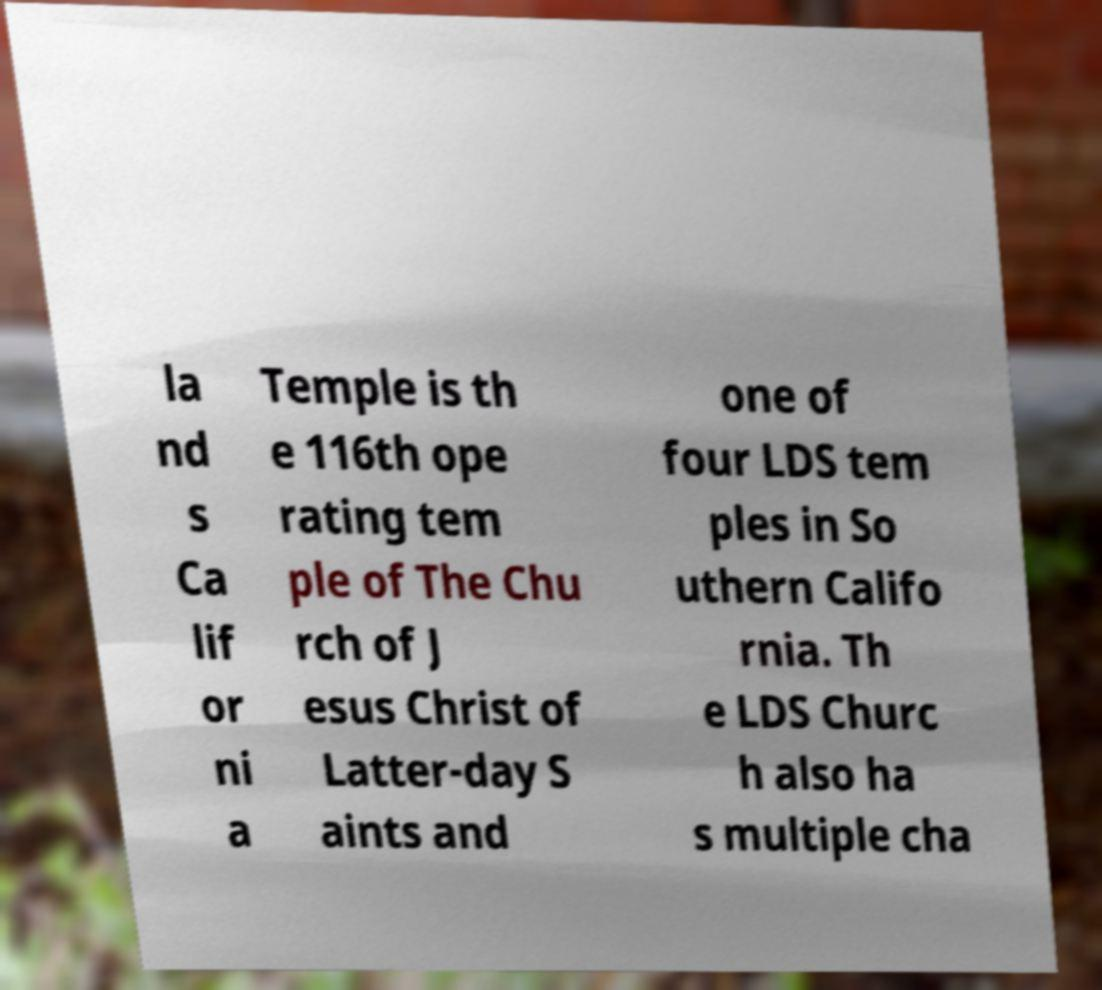Please identify and transcribe the text found in this image. la nd s Ca lif or ni a Temple is th e 116th ope rating tem ple of The Chu rch of J esus Christ of Latter-day S aints and one of four LDS tem ples in So uthern Califo rnia. Th e LDS Churc h also ha s multiple cha 